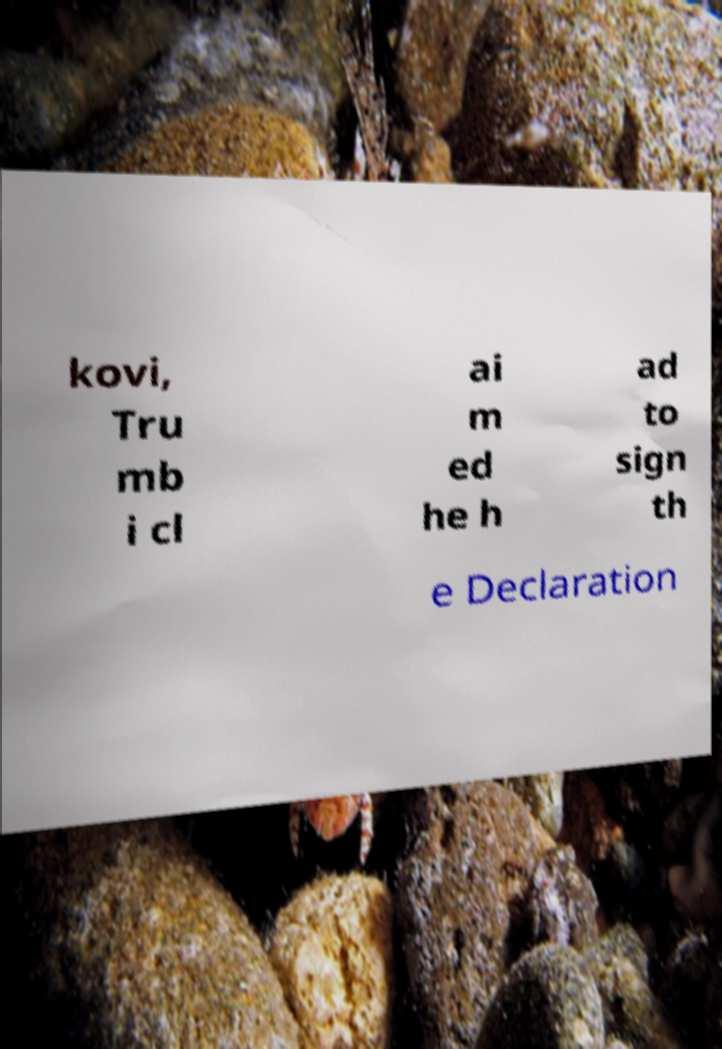For documentation purposes, I need the text within this image transcribed. Could you provide that? kovi, Tru mb i cl ai m ed he h ad to sign th e Declaration 